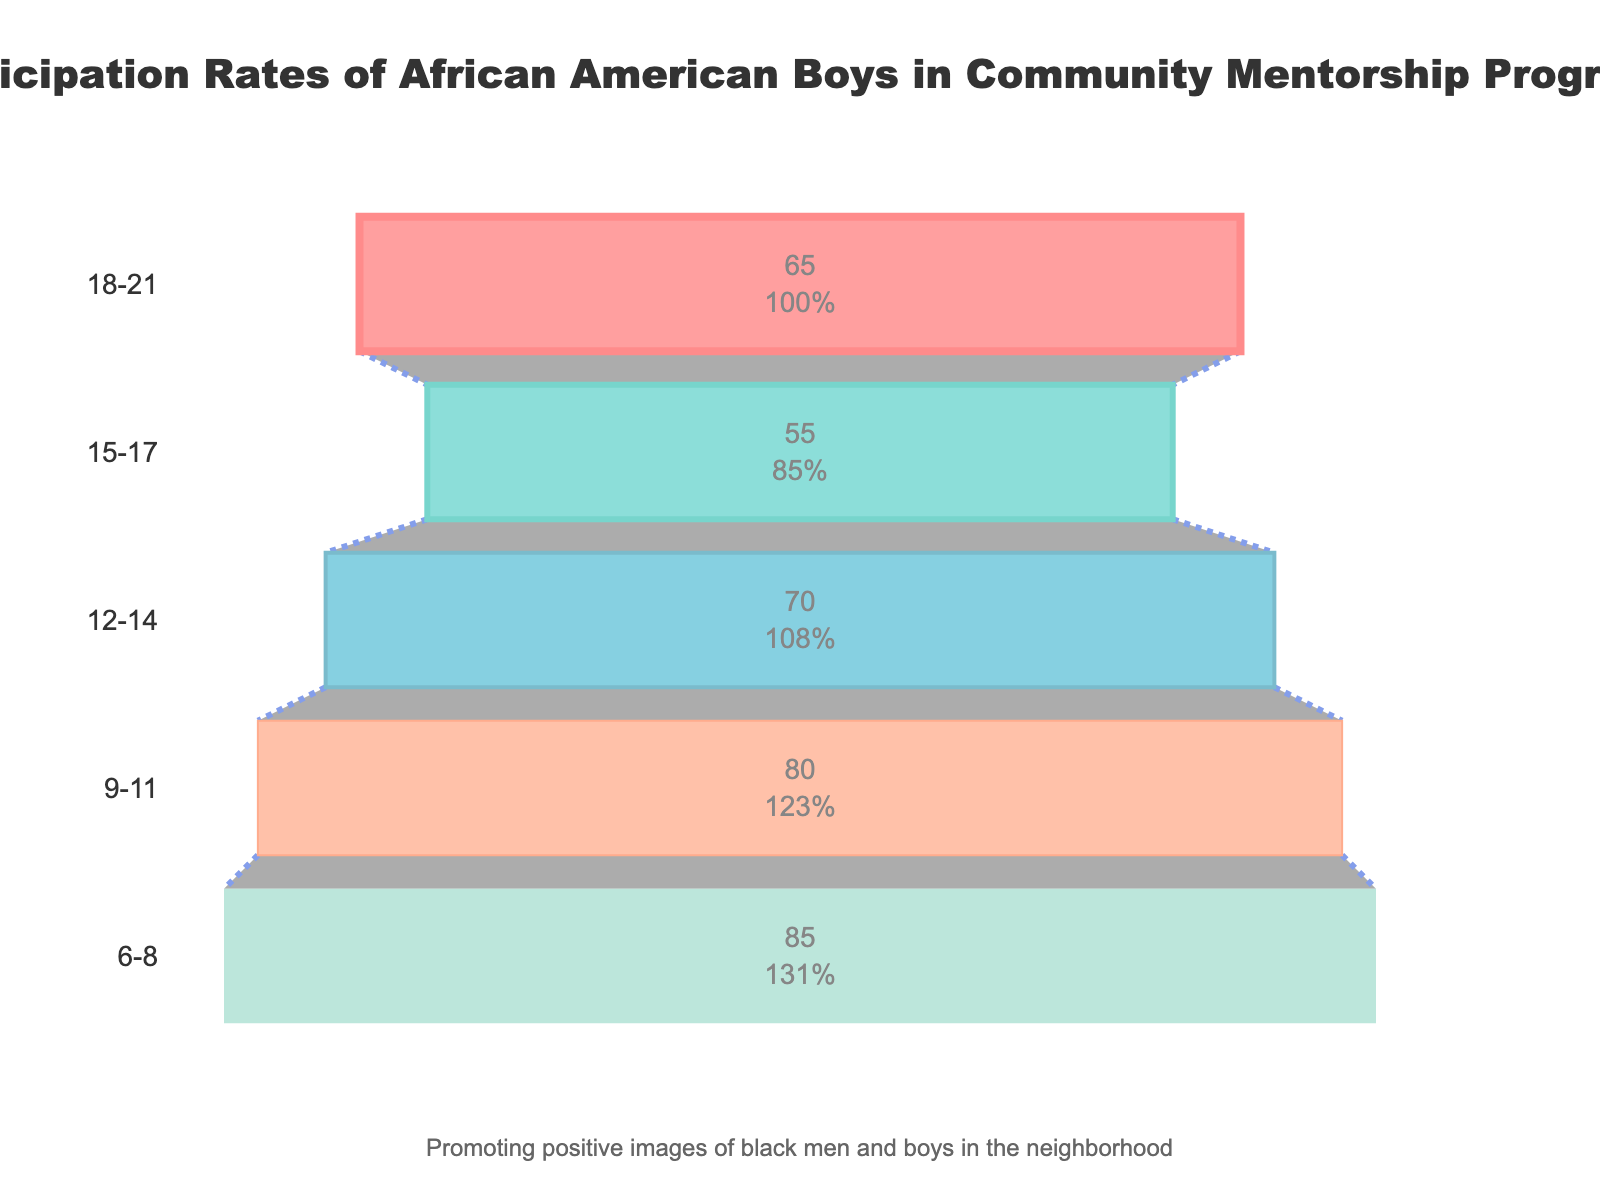What is the title of the chart? The title of the chart is displayed at the top and reads: "Participation Rates of African American Boys in Community Mentorship Programs".
Answer: Participation Rates of African American Boys in Community Mentorship Programs Which age group has the highest participation rate? By looking at the figure, we can see that the 6-8 age group has the highest participation rate at 85%.
Answer: 6-8 What is the participation rate for the 15-17 age group? The participation rate for the 15-17 age group is shown inside the funnel segment for that age group, which is 55%.
Answer: 55% Which age group has the lowest participation rate? The age group with the smallest portion of the funnel (at the top) has the lowest participation rate, which is the 18-21 age group with a 65% participation rate.
Answer: 18-21 What is the difference in participation rates between the 12-14 and 18-21 age groups? The participation rate for the 12-14 age group is 70%, and for the 18-21 age group, it is 65%. The difference is 70% - 65% = 5%.
Answer: 5% How does the participation rate of the 9-11 age group compare to that of the 6-8 age group? The participation rate for the 9-11 age group is 80%, while for the 6-8 age group, it is 85%. Thus, the 9-11 age group has a 5% lower participation rate compared to the 6-8 age group.
Answer: 5% lower What is the average participation rate across all age groups? Adding the participation rates: 65% + 55% + 70% + 80% + 85% = 355%. Dividing by the number of age groups (5) gives the average: 355% / 5 = 71%.
Answer: 71% Which age groups have a participation rate above the average rate? The average participation rate is 71%. The age groups 12-14 (70%), 9-11 (80%), and 6-8 (85%) are compared. Only 9-11 and 6-8 are above the average rate.
Answer: 9-11 and 6-8 How much higher is the participation rate of the 6-8 age group compared to the 15-17 age group? The 6-8 age group has an 85% rate, and the 15-17 age group has a 55% rate. The difference is 85% - 55% = 30%.
Answer: 30% 